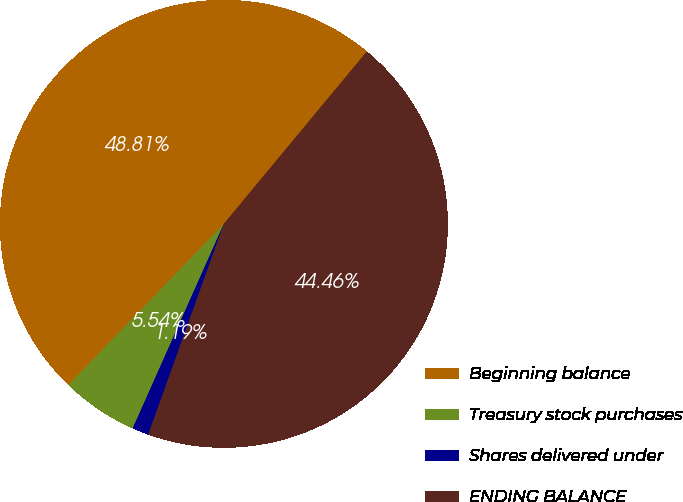Convert chart to OTSL. <chart><loc_0><loc_0><loc_500><loc_500><pie_chart><fcel>Beginning balance<fcel>Treasury stock purchases<fcel>Shares delivered under<fcel>ENDING BALANCE<nl><fcel>48.81%<fcel>5.54%<fcel>1.19%<fcel>44.46%<nl></chart> 